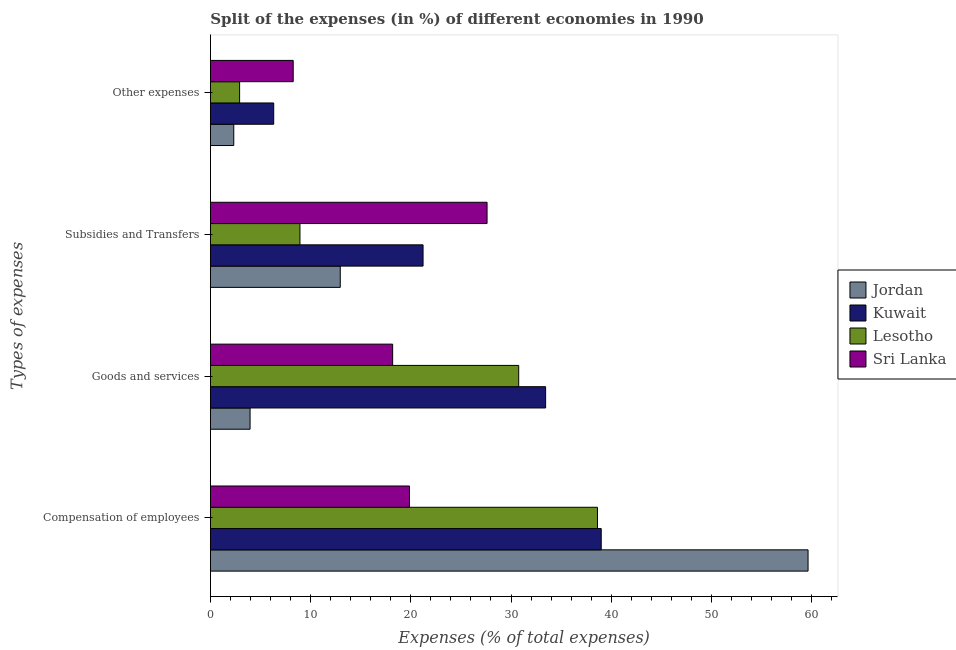Are the number of bars per tick equal to the number of legend labels?
Your answer should be very brief. Yes. Are the number of bars on each tick of the Y-axis equal?
Offer a terse response. Yes. How many bars are there on the 1st tick from the top?
Make the answer very short. 4. How many bars are there on the 3rd tick from the bottom?
Provide a short and direct response. 4. What is the label of the 4th group of bars from the top?
Keep it short and to the point. Compensation of employees. What is the percentage of amount spent on other expenses in Kuwait?
Offer a very short reply. 6.32. Across all countries, what is the maximum percentage of amount spent on other expenses?
Make the answer very short. 8.26. Across all countries, what is the minimum percentage of amount spent on other expenses?
Your answer should be compact. 2.33. In which country was the percentage of amount spent on subsidies maximum?
Provide a short and direct response. Sri Lanka. In which country was the percentage of amount spent on goods and services minimum?
Your answer should be compact. Jordan. What is the total percentage of amount spent on subsidies in the graph?
Keep it short and to the point. 70.73. What is the difference between the percentage of amount spent on subsidies in Kuwait and that in Lesotho?
Your answer should be very brief. 12.28. What is the difference between the percentage of amount spent on goods and services in Lesotho and the percentage of amount spent on subsidies in Kuwait?
Your answer should be very brief. 9.55. What is the average percentage of amount spent on goods and services per country?
Your response must be concise. 21.59. What is the difference between the percentage of amount spent on goods and services and percentage of amount spent on compensation of employees in Jordan?
Provide a short and direct response. -55.68. What is the ratio of the percentage of amount spent on compensation of employees in Sri Lanka to that in Lesotho?
Ensure brevity in your answer.  0.51. Is the percentage of amount spent on compensation of employees in Sri Lanka less than that in Jordan?
Keep it short and to the point. Yes. Is the difference between the percentage of amount spent on subsidies in Lesotho and Kuwait greater than the difference between the percentage of amount spent on goods and services in Lesotho and Kuwait?
Give a very brief answer. No. What is the difference between the highest and the second highest percentage of amount spent on other expenses?
Ensure brevity in your answer.  1.95. What is the difference between the highest and the lowest percentage of amount spent on other expenses?
Give a very brief answer. 5.93. Is the sum of the percentage of amount spent on subsidies in Kuwait and Lesotho greater than the maximum percentage of amount spent on compensation of employees across all countries?
Give a very brief answer. No. Is it the case that in every country, the sum of the percentage of amount spent on goods and services and percentage of amount spent on subsidies is greater than the sum of percentage of amount spent on other expenses and percentage of amount spent on compensation of employees?
Give a very brief answer. No. What does the 4th bar from the top in Goods and services represents?
Make the answer very short. Jordan. What does the 3rd bar from the bottom in Compensation of employees represents?
Ensure brevity in your answer.  Lesotho. How many bars are there?
Provide a succinct answer. 16. How many countries are there in the graph?
Give a very brief answer. 4. What is the difference between two consecutive major ticks on the X-axis?
Ensure brevity in your answer.  10. Does the graph contain grids?
Your response must be concise. No. What is the title of the graph?
Your answer should be compact. Split of the expenses (in %) of different economies in 1990. What is the label or title of the X-axis?
Your answer should be very brief. Expenses (% of total expenses). What is the label or title of the Y-axis?
Offer a terse response. Types of expenses. What is the Expenses (% of total expenses) of Jordan in Compensation of employees?
Provide a succinct answer. 59.64. What is the Expenses (% of total expenses) of Kuwait in Compensation of employees?
Ensure brevity in your answer.  39. What is the Expenses (% of total expenses) in Lesotho in Compensation of employees?
Keep it short and to the point. 38.63. What is the Expenses (% of total expenses) in Sri Lanka in Compensation of employees?
Ensure brevity in your answer.  19.87. What is the Expenses (% of total expenses) in Jordan in Goods and services?
Make the answer very short. 3.96. What is the Expenses (% of total expenses) of Kuwait in Goods and services?
Keep it short and to the point. 33.45. What is the Expenses (% of total expenses) in Lesotho in Goods and services?
Your response must be concise. 30.77. What is the Expenses (% of total expenses) of Sri Lanka in Goods and services?
Ensure brevity in your answer.  18.19. What is the Expenses (% of total expenses) of Jordan in Subsidies and Transfers?
Provide a succinct answer. 12.96. What is the Expenses (% of total expenses) of Kuwait in Subsidies and Transfers?
Offer a very short reply. 21.22. What is the Expenses (% of total expenses) of Lesotho in Subsidies and Transfers?
Offer a very short reply. 8.94. What is the Expenses (% of total expenses) of Sri Lanka in Subsidies and Transfers?
Ensure brevity in your answer.  27.61. What is the Expenses (% of total expenses) in Jordan in Other expenses?
Provide a short and direct response. 2.33. What is the Expenses (% of total expenses) in Kuwait in Other expenses?
Ensure brevity in your answer.  6.32. What is the Expenses (% of total expenses) in Lesotho in Other expenses?
Ensure brevity in your answer.  2.92. What is the Expenses (% of total expenses) in Sri Lanka in Other expenses?
Provide a succinct answer. 8.26. Across all Types of expenses, what is the maximum Expenses (% of total expenses) of Jordan?
Offer a terse response. 59.64. Across all Types of expenses, what is the maximum Expenses (% of total expenses) of Kuwait?
Give a very brief answer. 39. Across all Types of expenses, what is the maximum Expenses (% of total expenses) in Lesotho?
Give a very brief answer. 38.63. Across all Types of expenses, what is the maximum Expenses (% of total expenses) in Sri Lanka?
Give a very brief answer. 27.61. Across all Types of expenses, what is the minimum Expenses (% of total expenses) of Jordan?
Ensure brevity in your answer.  2.33. Across all Types of expenses, what is the minimum Expenses (% of total expenses) of Kuwait?
Your answer should be compact. 6.32. Across all Types of expenses, what is the minimum Expenses (% of total expenses) in Lesotho?
Offer a terse response. 2.92. Across all Types of expenses, what is the minimum Expenses (% of total expenses) in Sri Lanka?
Give a very brief answer. 8.26. What is the total Expenses (% of total expenses) in Jordan in the graph?
Ensure brevity in your answer.  78.9. What is the total Expenses (% of total expenses) in Kuwait in the graph?
Offer a very short reply. 100. What is the total Expenses (% of total expenses) in Lesotho in the graph?
Keep it short and to the point. 81.25. What is the total Expenses (% of total expenses) in Sri Lanka in the graph?
Give a very brief answer. 73.93. What is the difference between the Expenses (% of total expenses) of Jordan in Compensation of employees and that in Goods and services?
Provide a succinct answer. 55.68. What is the difference between the Expenses (% of total expenses) of Kuwait in Compensation of employees and that in Goods and services?
Offer a very short reply. 5.55. What is the difference between the Expenses (% of total expenses) of Lesotho in Compensation of employees and that in Goods and services?
Your response must be concise. 7.86. What is the difference between the Expenses (% of total expenses) in Sri Lanka in Compensation of employees and that in Goods and services?
Give a very brief answer. 1.68. What is the difference between the Expenses (% of total expenses) in Jordan in Compensation of employees and that in Subsidies and Transfers?
Make the answer very short. 46.68. What is the difference between the Expenses (% of total expenses) in Kuwait in Compensation of employees and that in Subsidies and Transfers?
Make the answer very short. 17.78. What is the difference between the Expenses (% of total expenses) in Lesotho in Compensation of employees and that in Subsidies and Transfers?
Your response must be concise. 29.69. What is the difference between the Expenses (% of total expenses) in Sri Lanka in Compensation of employees and that in Subsidies and Transfers?
Provide a short and direct response. -7.75. What is the difference between the Expenses (% of total expenses) of Jordan in Compensation of employees and that in Other expenses?
Give a very brief answer. 57.31. What is the difference between the Expenses (% of total expenses) of Kuwait in Compensation of employees and that in Other expenses?
Keep it short and to the point. 32.69. What is the difference between the Expenses (% of total expenses) of Lesotho in Compensation of employees and that in Other expenses?
Ensure brevity in your answer.  35.71. What is the difference between the Expenses (% of total expenses) in Sri Lanka in Compensation of employees and that in Other expenses?
Ensure brevity in your answer.  11.6. What is the difference between the Expenses (% of total expenses) in Jordan in Goods and services and that in Subsidies and Transfers?
Ensure brevity in your answer.  -9. What is the difference between the Expenses (% of total expenses) in Kuwait in Goods and services and that in Subsidies and Transfers?
Provide a succinct answer. 12.23. What is the difference between the Expenses (% of total expenses) in Lesotho in Goods and services and that in Subsidies and Transfers?
Ensure brevity in your answer.  21.83. What is the difference between the Expenses (% of total expenses) in Sri Lanka in Goods and services and that in Subsidies and Transfers?
Offer a terse response. -9.42. What is the difference between the Expenses (% of total expenses) of Jordan in Goods and services and that in Other expenses?
Keep it short and to the point. 1.63. What is the difference between the Expenses (% of total expenses) of Kuwait in Goods and services and that in Other expenses?
Your answer should be compact. 27.14. What is the difference between the Expenses (% of total expenses) of Lesotho in Goods and services and that in Other expenses?
Keep it short and to the point. 27.85. What is the difference between the Expenses (% of total expenses) in Sri Lanka in Goods and services and that in Other expenses?
Offer a terse response. 9.92. What is the difference between the Expenses (% of total expenses) in Jordan in Subsidies and Transfers and that in Other expenses?
Provide a succinct answer. 10.63. What is the difference between the Expenses (% of total expenses) in Kuwait in Subsidies and Transfers and that in Other expenses?
Offer a terse response. 14.9. What is the difference between the Expenses (% of total expenses) in Lesotho in Subsidies and Transfers and that in Other expenses?
Offer a very short reply. 6.02. What is the difference between the Expenses (% of total expenses) of Sri Lanka in Subsidies and Transfers and that in Other expenses?
Ensure brevity in your answer.  19.35. What is the difference between the Expenses (% of total expenses) in Jordan in Compensation of employees and the Expenses (% of total expenses) in Kuwait in Goods and services?
Your answer should be compact. 26.19. What is the difference between the Expenses (% of total expenses) in Jordan in Compensation of employees and the Expenses (% of total expenses) in Lesotho in Goods and services?
Make the answer very short. 28.88. What is the difference between the Expenses (% of total expenses) in Jordan in Compensation of employees and the Expenses (% of total expenses) in Sri Lanka in Goods and services?
Give a very brief answer. 41.46. What is the difference between the Expenses (% of total expenses) in Kuwait in Compensation of employees and the Expenses (% of total expenses) in Lesotho in Goods and services?
Offer a terse response. 8.24. What is the difference between the Expenses (% of total expenses) in Kuwait in Compensation of employees and the Expenses (% of total expenses) in Sri Lanka in Goods and services?
Offer a very short reply. 20.82. What is the difference between the Expenses (% of total expenses) of Lesotho in Compensation of employees and the Expenses (% of total expenses) of Sri Lanka in Goods and services?
Give a very brief answer. 20.44. What is the difference between the Expenses (% of total expenses) in Jordan in Compensation of employees and the Expenses (% of total expenses) in Kuwait in Subsidies and Transfers?
Provide a succinct answer. 38.42. What is the difference between the Expenses (% of total expenses) of Jordan in Compensation of employees and the Expenses (% of total expenses) of Lesotho in Subsidies and Transfers?
Ensure brevity in your answer.  50.71. What is the difference between the Expenses (% of total expenses) of Jordan in Compensation of employees and the Expenses (% of total expenses) of Sri Lanka in Subsidies and Transfers?
Give a very brief answer. 32.03. What is the difference between the Expenses (% of total expenses) of Kuwait in Compensation of employees and the Expenses (% of total expenses) of Lesotho in Subsidies and Transfers?
Provide a short and direct response. 30.06. What is the difference between the Expenses (% of total expenses) of Kuwait in Compensation of employees and the Expenses (% of total expenses) of Sri Lanka in Subsidies and Transfers?
Provide a short and direct response. 11.39. What is the difference between the Expenses (% of total expenses) of Lesotho in Compensation of employees and the Expenses (% of total expenses) of Sri Lanka in Subsidies and Transfers?
Offer a very short reply. 11.02. What is the difference between the Expenses (% of total expenses) in Jordan in Compensation of employees and the Expenses (% of total expenses) in Kuwait in Other expenses?
Keep it short and to the point. 53.33. What is the difference between the Expenses (% of total expenses) in Jordan in Compensation of employees and the Expenses (% of total expenses) in Lesotho in Other expenses?
Your answer should be very brief. 56.73. What is the difference between the Expenses (% of total expenses) in Jordan in Compensation of employees and the Expenses (% of total expenses) in Sri Lanka in Other expenses?
Offer a very short reply. 51.38. What is the difference between the Expenses (% of total expenses) in Kuwait in Compensation of employees and the Expenses (% of total expenses) in Lesotho in Other expenses?
Your answer should be compact. 36.09. What is the difference between the Expenses (% of total expenses) in Kuwait in Compensation of employees and the Expenses (% of total expenses) in Sri Lanka in Other expenses?
Keep it short and to the point. 30.74. What is the difference between the Expenses (% of total expenses) of Lesotho in Compensation of employees and the Expenses (% of total expenses) of Sri Lanka in Other expenses?
Keep it short and to the point. 30.36. What is the difference between the Expenses (% of total expenses) of Jordan in Goods and services and the Expenses (% of total expenses) of Kuwait in Subsidies and Transfers?
Give a very brief answer. -17.26. What is the difference between the Expenses (% of total expenses) of Jordan in Goods and services and the Expenses (% of total expenses) of Lesotho in Subsidies and Transfers?
Ensure brevity in your answer.  -4.98. What is the difference between the Expenses (% of total expenses) of Jordan in Goods and services and the Expenses (% of total expenses) of Sri Lanka in Subsidies and Transfers?
Keep it short and to the point. -23.65. What is the difference between the Expenses (% of total expenses) in Kuwait in Goods and services and the Expenses (% of total expenses) in Lesotho in Subsidies and Transfers?
Ensure brevity in your answer.  24.52. What is the difference between the Expenses (% of total expenses) in Kuwait in Goods and services and the Expenses (% of total expenses) in Sri Lanka in Subsidies and Transfers?
Ensure brevity in your answer.  5.84. What is the difference between the Expenses (% of total expenses) of Lesotho in Goods and services and the Expenses (% of total expenses) of Sri Lanka in Subsidies and Transfers?
Your answer should be compact. 3.16. What is the difference between the Expenses (% of total expenses) of Jordan in Goods and services and the Expenses (% of total expenses) of Kuwait in Other expenses?
Ensure brevity in your answer.  -2.36. What is the difference between the Expenses (% of total expenses) of Jordan in Goods and services and the Expenses (% of total expenses) of Lesotho in Other expenses?
Give a very brief answer. 1.05. What is the difference between the Expenses (% of total expenses) of Jordan in Goods and services and the Expenses (% of total expenses) of Sri Lanka in Other expenses?
Offer a terse response. -4.3. What is the difference between the Expenses (% of total expenses) of Kuwait in Goods and services and the Expenses (% of total expenses) of Lesotho in Other expenses?
Ensure brevity in your answer.  30.54. What is the difference between the Expenses (% of total expenses) of Kuwait in Goods and services and the Expenses (% of total expenses) of Sri Lanka in Other expenses?
Offer a very short reply. 25.19. What is the difference between the Expenses (% of total expenses) of Lesotho in Goods and services and the Expenses (% of total expenses) of Sri Lanka in Other expenses?
Offer a very short reply. 22.5. What is the difference between the Expenses (% of total expenses) in Jordan in Subsidies and Transfers and the Expenses (% of total expenses) in Kuwait in Other expenses?
Offer a very short reply. 6.64. What is the difference between the Expenses (% of total expenses) in Jordan in Subsidies and Transfers and the Expenses (% of total expenses) in Lesotho in Other expenses?
Offer a very short reply. 10.05. What is the difference between the Expenses (% of total expenses) of Jordan in Subsidies and Transfers and the Expenses (% of total expenses) of Sri Lanka in Other expenses?
Keep it short and to the point. 4.7. What is the difference between the Expenses (% of total expenses) in Kuwait in Subsidies and Transfers and the Expenses (% of total expenses) in Lesotho in Other expenses?
Your response must be concise. 18.31. What is the difference between the Expenses (% of total expenses) of Kuwait in Subsidies and Transfers and the Expenses (% of total expenses) of Sri Lanka in Other expenses?
Provide a short and direct response. 12.96. What is the difference between the Expenses (% of total expenses) of Lesotho in Subsidies and Transfers and the Expenses (% of total expenses) of Sri Lanka in Other expenses?
Provide a short and direct response. 0.67. What is the average Expenses (% of total expenses) of Jordan per Types of expenses?
Provide a succinct answer. 19.73. What is the average Expenses (% of total expenses) of Lesotho per Types of expenses?
Give a very brief answer. 20.31. What is the average Expenses (% of total expenses) of Sri Lanka per Types of expenses?
Your answer should be compact. 18.48. What is the difference between the Expenses (% of total expenses) of Jordan and Expenses (% of total expenses) of Kuwait in Compensation of employees?
Ensure brevity in your answer.  20.64. What is the difference between the Expenses (% of total expenses) of Jordan and Expenses (% of total expenses) of Lesotho in Compensation of employees?
Offer a very short reply. 21.02. What is the difference between the Expenses (% of total expenses) in Jordan and Expenses (% of total expenses) in Sri Lanka in Compensation of employees?
Ensure brevity in your answer.  39.78. What is the difference between the Expenses (% of total expenses) of Kuwait and Expenses (% of total expenses) of Lesotho in Compensation of employees?
Make the answer very short. 0.38. What is the difference between the Expenses (% of total expenses) of Kuwait and Expenses (% of total expenses) of Sri Lanka in Compensation of employees?
Give a very brief answer. 19.14. What is the difference between the Expenses (% of total expenses) of Lesotho and Expenses (% of total expenses) of Sri Lanka in Compensation of employees?
Provide a succinct answer. 18.76. What is the difference between the Expenses (% of total expenses) of Jordan and Expenses (% of total expenses) of Kuwait in Goods and services?
Your answer should be very brief. -29.49. What is the difference between the Expenses (% of total expenses) in Jordan and Expenses (% of total expenses) in Lesotho in Goods and services?
Give a very brief answer. -26.81. What is the difference between the Expenses (% of total expenses) in Jordan and Expenses (% of total expenses) in Sri Lanka in Goods and services?
Provide a succinct answer. -14.23. What is the difference between the Expenses (% of total expenses) of Kuwait and Expenses (% of total expenses) of Lesotho in Goods and services?
Ensure brevity in your answer.  2.69. What is the difference between the Expenses (% of total expenses) in Kuwait and Expenses (% of total expenses) in Sri Lanka in Goods and services?
Your answer should be very brief. 15.27. What is the difference between the Expenses (% of total expenses) of Lesotho and Expenses (% of total expenses) of Sri Lanka in Goods and services?
Provide a short and direct response. 12.58. What is the difference between the Expenses (% of total expenses) in Jordan and Expenses (% of total expenses) in Kuwait in Subsidies and Transfers?
Give a very brief answer. -8.26. What is the difference between the Expenses (% of total expenses) of Jordan and Expenses (% of total expenses) of Lesotho in Subsidies and Transfers?
Make the answer very short. 4.02. What is the difference between the Expenses (% of total expenses) in Jordan and Expenses (% of total expenses) in Sri Lanka in Subsidies and Transfers?
Your answer should be compact. -14.65. What is the difference between the Expenses (% of total expenses) in Kuwait and Expenses (% of total expenses) in Lesotho in Subsidies and Transfers?
Make the answer very short. 12.28. What is the difference between the Expenses (% of total expenses) of Kuwait and Expenses (% of total expenses) of Sri Lanka in Subsidies and Transfers?
Offer a terse response. -6.39. What is the difference between the Expenses (% of total expenses) in Lesotho and Expenses (% of total expenses) in Sri Lanka in Subsidies and Transfers?
Give a very brief answer. -18.67. What is the difference between the Expenses (% of total expenses) in Jordan and Expenses (% of total expenses) in Kuwait in Other expenses?
Your response must be concise. -3.98. What is the difference between the Expenses (% of total expenses) of Jordan and Expenses (% of total expenses) of Lesotho in Other expenses?
Give a very brief answer. -0.58. What is the difference between the Expenses (% of total expenses) of Jordan and Expenses (% of total expenses) of Sri Lanka in Other expenses?
Make the answer very short. -5.93. What is the difference between the Expenses (% of total expenses) of Kuwait and Expenses (% of total expenses) of Lesotho in Other expenses?
Your response must be concise. 3.4. What is the difference between the Expenses (% of total expenses) in Kuwait and Expenses (% of total expenses) in Sri Lanka in Other expenses?
Offer a terse response. -1.95. What is the difference between the Expenses (% of total expenses) of Lesotho and Expenses (% of total expenses) of Sri Lanka in Other expenses?
Your response must be concise. -5.35. What is the ratio of the Expenses (% of total expenses) of Jordan in Compensation of employees to that in Goods and services?
Give a very brief answer. 15.06. What is the ratio of the Expenses (% of total expenses) in Kuwait in Compensation of employees to that in Goods and services?
Your response must be concise. 1.17. What is the ratio of the Expenses (% of total expenses) of Lesotho in Compensation of employees to that in Goods and services?
Provide a short and direct response. 1.26. What is the ratio of the Expenses (% of total expenses) of Sri Lanka in Compensation of employees to that in Goods and services?
Your answer should be very brief. 1.09. What is the ratio of the Expenses (% of total expenses) in Jordan in Compensation of employees to that in Subsidies and Transfers?
Ensure brevity in your answer.  4.6. What is the ratio of the Expenses (% of total expenses) in Kuwait in Compensation of employees to that in Subsidies and Transfers?
Make the answer very short. 1.84. What is the ratio of the Expenses (% of total expenses) of Lesotho in Compensation of employees to that in Subsidies and Transfers?
Offer a terse response. 4.32. What is the ratio of the Expenses (% of total expenses) in Sri Lanka in Compensation of employees to that in Subsidies and Transfers?
Provide a short and direct response. 0.72. What is the ratio of the Expenses (% of total expenses) in Jordan in Compensation of employees to that in Other expenses?
Offer a very short reply. 25.56. What is the ratio of the Expenses (% of total expenses) in Kuwait in Compensation of employees to that in Other expenses?
Ensure brevity in your answer.  6.17. What is the ratio of the Expenses (% of total expenses) of Lesotho in Compensation of employees to that in Other expenses?
Provide a succinct answer. 13.25. What is the ratio of the Expenses (% of total expenses) of Sri Lanka in Compensation of employees to that in Other expenses?
Offer a terse response. 2.4. What is the ratio of the Expenses (% of total expenses) in Jordan in Goods and services to that in Subsidies and Transfers?
Ensure brevity in your answer.  0.31. What is the ratio of the Expenses (% of total expenses) in Kuwait in Goods and services to that in Subsidies and Transfers?
Give a very brief answer. 1.58. What is the ratio of the Expenses (% of total expenses) in Lesotho in Goods and services to that in Subsidies and Transfers?
Your answer should be very brief. 3.44. What is the ratio of the Expenses (% of total expenses) of Sri Lanka in Goods and services to that in Subsidies and Transfers?
Keep it short and to the point. 0.66. What is the ratio of the Expenses (% of total expenses) of Jordan in Goods and services to that in Other expenses?
Give a very brief answer. 1.7. What is the ratio of the Expenses (% of total expenses) of Kuwait in Goods and services to that in Other expenses?
Make the answer very short. 5.29. What is the ratio of the Expenses (% of total expenses) of Lesotho in Goods and services to that in Other expenses?
Make the answer very short. 10.55. What is the ratio of the Expenses (% of total expenses) in Sri Lanka in Goods and services to that in Other expenses?
Give a very brief answer. 2.2. What is the ratio of the Expenses (% of total expenses) in Jordan in Subsidies and Transfers to that in Other expenses?
Provide a short and direct response. 5.55. What is the ratio of the Expenses (% of total expenses) in Kuwait in Subsidies and Transfers to that in Other expenses?
Provide a succinct answer. 3.36. What is the ratio of the Expenses (% of total expenses) of Lesotho in Subsidies and Transfers to that in Other expenses?
Provide a short and direct response. 3.07. What is the ratio of the Expenses (% of total expenses) in Sri Lanka in Subsidies and Transfers to that in Other expenses?
Ensure brevity in your answer.  3.34. What is the difference between the highest and the second highest Expenses (% of total expenses) of Jordan?
Ensure brevity in your answer.  46.68. What is the difference between the highest and the second highest Expenses (% of total expenses) of Kuwait?
Ensure brevity in your answer.  5.55. What is the difference between the highest and the second highest Expenses (% of total expenses) of Lesotho?
Your answer should be compact. 7.86. What is the difference between the highest and the second highest Expenses (% of total expenses) in Sri Lanka?
Offer a very short reply. 7.75. What is the difference between the highest and the lowest Expenses (% of total expenses) in Jordan?
Offer a very short reply. 57.31. What is the difference between the highest and the lowest Expenses (% of total expenses) in Kuwait?
Provide a succinct answer. 32.69. What is the difference between the highest and the lowest Expenses (% of total expenses) of Lesotho?
Keep it short and to the point. 35.71. What is the difference between the highest and the lowest Expenses (% of total expenses) of Sri Lanka?
Provide a succinct answer. 19.35. 